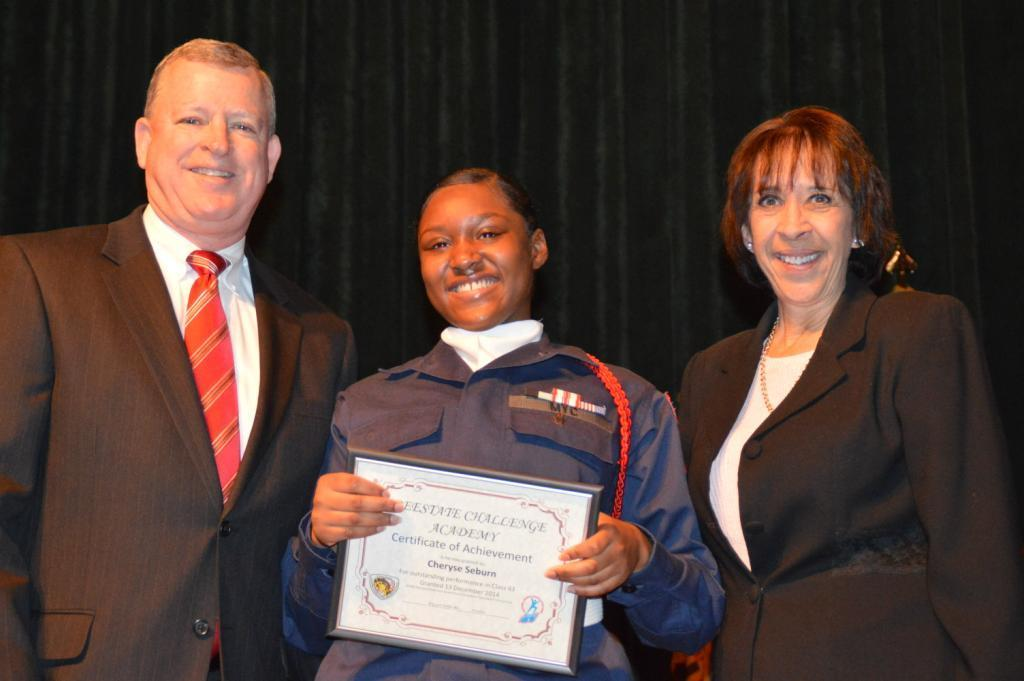How many people are present in the image? There are three people in the image. What can be observed about the clothing of the people in the image? The people are wearing different color dresses. What is one person holding in the image? One person is holding a board. What is the color of the background in the image? The background of the image is black. Is there an umbrella visible in the image? No, there is no umbrella present in the image. Are the people in the image jumping up and down? There is no indication in the image that the people are jumping; they are standing still. 